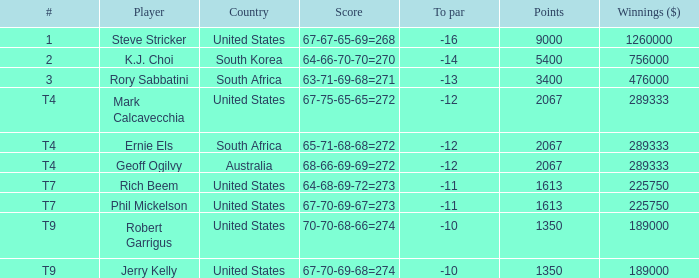Can you provide the point count for south korea? 1.0. 